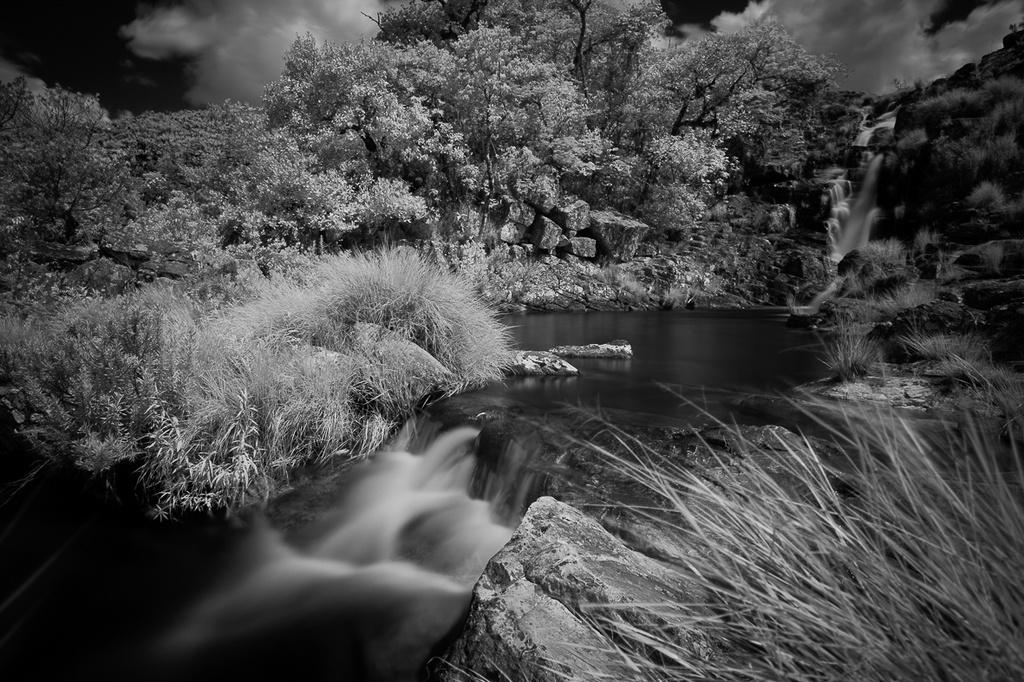What type of vegetation can be seen in the image? There are trees in the image. What other natural elements can be seen in the image? There are rocks and grass visible in the image. What is the main feature in the image? There is a waterfall in the image. What is visible in the background of the image? There is a sky visible in the background of the image, with clouds present. What type of skirt is the waterfall wearing in the image? The waterfall is not a person and therefore cannot wear a skirt. Is there a competition taking place near the waterfall in the image? There is no indication of a competition in the image; it primarily features the waterfall and surrounding natural elements. 